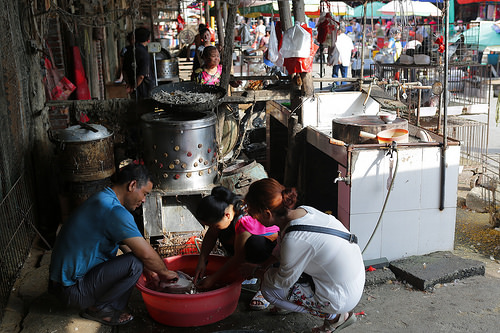<image>
Can you confirm if the women is on the men? No. The women is not positioned on the men. They may be near each other, but the women is not supported by or resting on top of the men. Where is the bucket in relation to the man? Is it next to the man? Yes. The bucket is positioned adjacent to the man, located nearby in the same general area. 